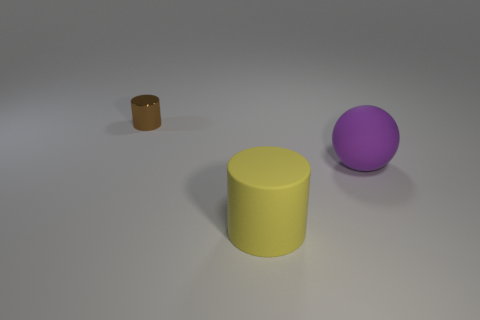Subtract all purple cylinders. Subtract all yellow cubes. How many cylinders are left? 2 Subtract all cyan blocks. How many brown balls are left? 0 Add 2 big things. How many purples exist? 0 Subtract all cylinders. Subtract all green objects. How many objects are left? 1 Add 1 large cylinders. How many large cylinders are left? 2 Add 3 cyan shiny cylinders. How many cyan shiny cylinders exist? 3 Add 2 big matte balls. How many objects exist? 5 Subtract all yellow cylinders. How many cylinders are left? 1 Subtract 0 blue balls. How many objects are left? 3 Subtract all balls. How many objects are left? 2 